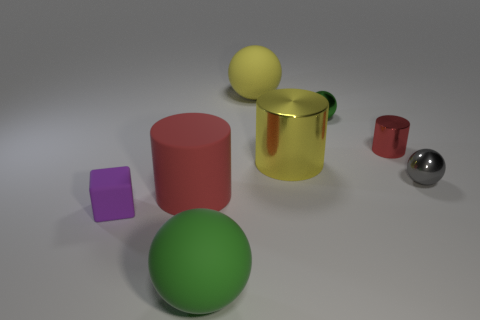Add 2 gray things. How many objects exist? 10 Subtract all blocks. How many objects are left? 7 Add 3 small red cylinders. How many small red cylinders are left? 4 Add 2 cyan cylinders. How many cyan cylinders exist? 2 Subtract 1 yellow cylinders. How many objects are left? 7 Subtract all small gray rubber spheres. Subtract all yellow balls. How many objects are left? 7 